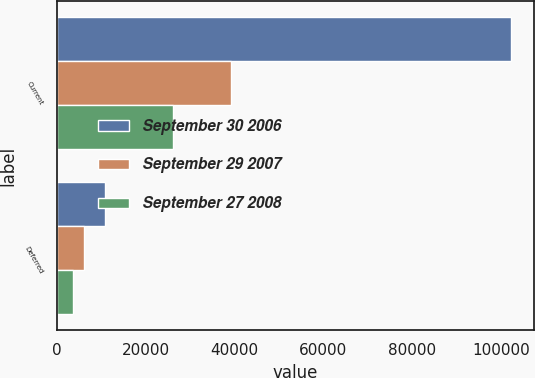Convert chart. <chart><loc_0><loc_0><loc_500><loc_500><stacked_bar_chart><ecel><fcel>Current<fcel>Deferred<nl><fcel>September 30 2006<fcel>102212<fcel>10835<nl><fcel>September 29 2007<fcel>39096<fcel>6053<nl><fcel>September 27 2008<fcel>26164<fcel>3540<nl></chart> 